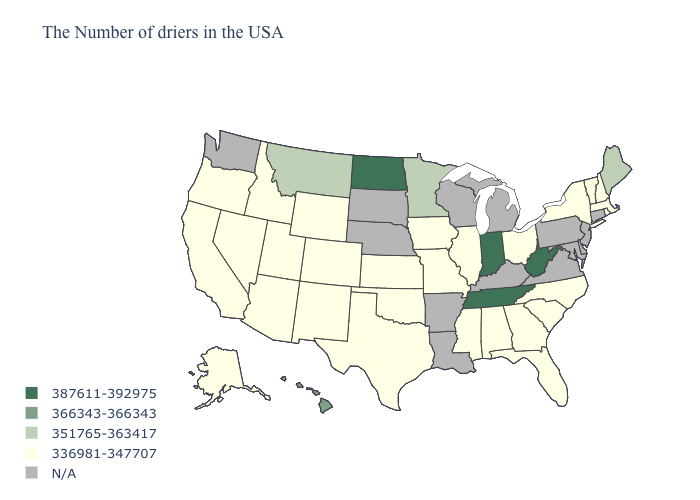What is the lowest value in the USA?
Answer briefly. 336981-347707. What is the value of Iowa?
Give a very brief answer. 336981-347707. Which states hav the highest value in the MidWest?
Write a very short answer. Indiana, North Dakota. What is the lowest value in states that border Montana?
Write a very short answer. 336981-347707. What is the highest value in the MidWest ?
Answer briefly. 387611-392975. Does the map have missing data?
Short answer required. Yes. What is the value of Colorado?
Be succinct. 336981-347707. What is the value of Missouri?
Quick response, please. 336981-347707. Which states hav the highest value in the MidWest?
Keep it brief. Indiana, North Dakota. Which states have the lowest value in the USA?
Quick response, please. Massachusetts, Rhode Island, New Hampshire, Vermont, New York, North Carolina, South Carolina, Ohio, Florida, Georgia, Alabama, Illinois, Mississippi, Missouri, Iowa, Kansas, Oklahoma, Texas, Wyoming, Colorado, New Mexico, Utah, Arizona, Idaho, Nevada, California, Oregon, Alaska. What is the highest value in the USA?
Be succinct. 387611-392975. What is the highest value in states that border Ohio?
Write a very short answer. 387611-392975. 